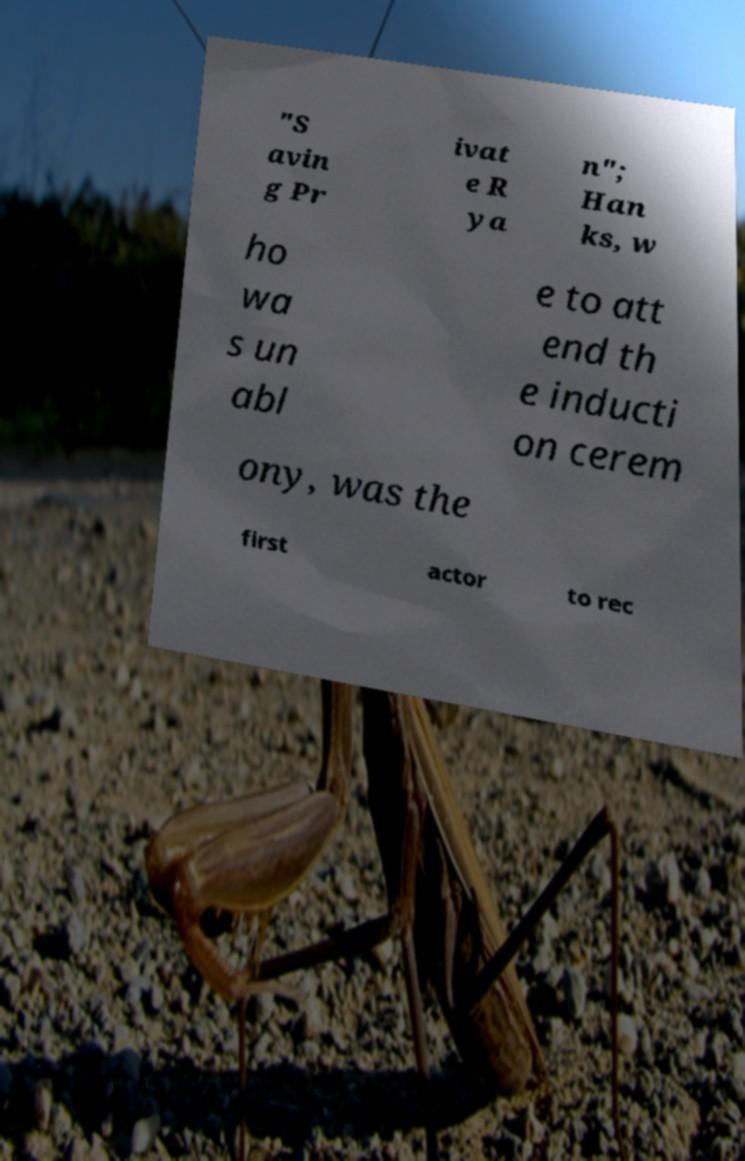Can you accurately transcribe the text from the provided image for me? "S avin g Pr ivat e R ya n"; Han ks, w ho wa s un abl e to att end th e inducti on cerem ony, was the first actor to rec 